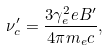Convert formula to latex. <formula><loc_0><loc_0><loc_500><loc_500>\nu ^ { \prime } _ { c } = \frac { 3 \gamma _ { e } ^ { 2 } e B ^ { \prime } } { 4 \pi m _ { e } c } ,</formula> 